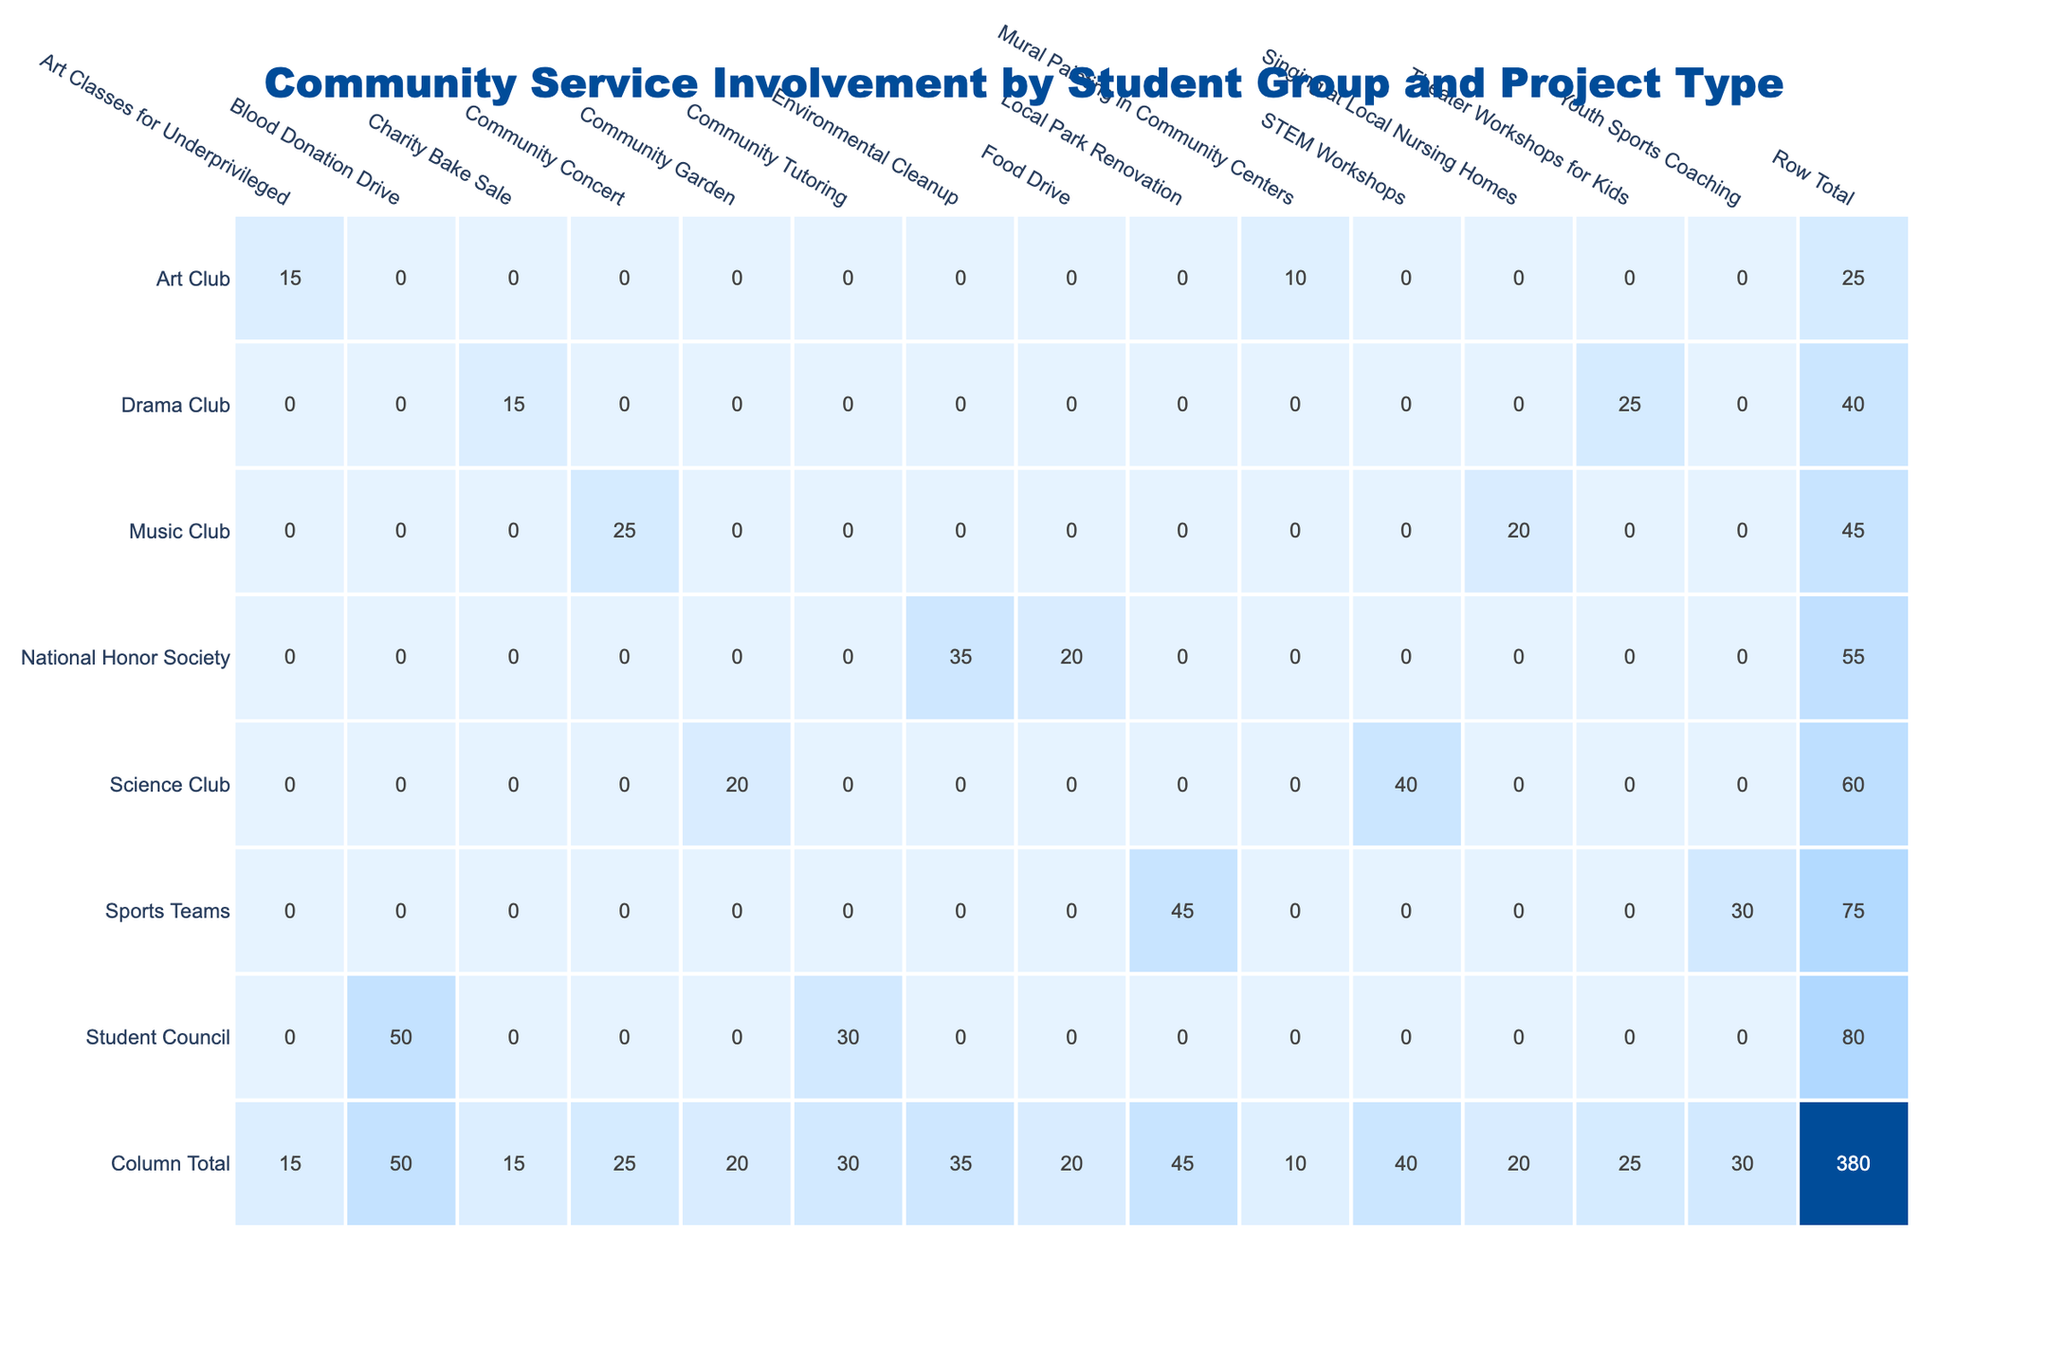What is the total involvement count for the Student Council? The total involvement count for the Student Council is calculated by adding the counts of the two projects it participated in: Blood Donation Drive (50) and Community Tutoring (30). Therefore, 50 + 30 = 80.
Answer: 80 Which project type has the highest involvement count? By examining all the projects and their respective involvement counts, the Blood Donation Drive has the highest count at 50.
Answer: Blood Donation Drive Does the Music Club have more involvement in the Community Concert than in Singing at Local Nursing Homes? The involvement count for the Community Concert is 25, while for Singing at Local Nursing Homes it is 20. Since 25 is greater than 20, the fact is true.
Answer: Yes What is the average involvement count for the Drama Club? The Drama Club has two project types: Charity Bake Sale (15) and Theater Workshops for Kids (25). To find the average, first sum these counts: 15 + 25 = 40, and then divide by the number of projects (2): 40 / 2 = 20.
Answer: 20 Which student group has the lowest total involvement count? To find the group with the lowest total involvement, we compute the total for each group: National Honor Society (55), Student Council (80), Drama Club (40), Science Club (60), Sports Teams (75), and Art Club (25). The Art Club has the lowest count at 25.
Answer: Art Club Is there any student group that participated in more than one project type? Several groups participated in multiple project types, including the Student Council, Drama Club, Science Club, Sports Teams, and Music Club. Therefore, it is true that some groups participated in more than one project type.
Answer: Yes What is the difference in involvement count between Sports Teams and National Honor Society? The Sports Teams have a total count of 75, and the National Honor Society has 55. The difference is 75 - 55 = 20.
Answer: 20 What is the total involvement for environmental project types across all student groups? The only environmental project type listed is the Environmental Cleanup, which had an involvement count of 35 from the National Honor Society. Thus, the total for environmental project types is 35.
Answer: 35 Which student group has the highest involvement in creative projects? The creative projects involve Mural Painting in Community Centers (10), Art Classes for Underprivileged (15), Charity Bake Sale (15), and Theater Workshops for Kids (25). The Drama Club has the highest count of 40 when adding these various counts (15 + 25).
Answer: Drama Club 